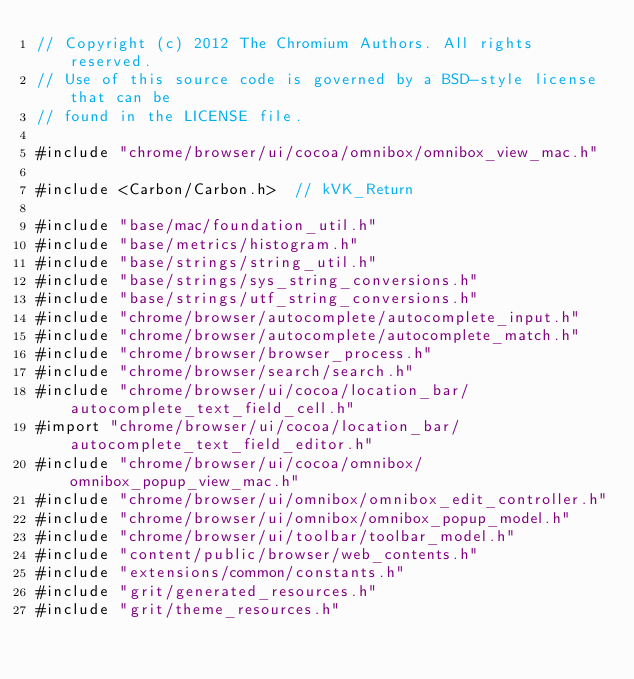<code> <loc_0><loc_0><loc_500><loc_500><_ObjectiveC_>// Copyright (c) 2012 The Chromium Authors. All rights reserved.
// Use of this source code is governed by a BSD-style license that can be
// found in the LICENSE file.

#include "chrome/browser/ui/cocoa/omnibox/omnibox_view_mac.h"

#include <Carbon/Carbon.h>  // kVK_Return

#include "base/mac/foundation_util.h"
#include "base/metrics/histogram.h"
#include "base/strings/string_util.h"
#include "base/strings/sys_string_conversions.h"
#include "base/strings/utf_string_conversions.h"
#include "chrome/browser/autocomplete/autocomplete_input.h"
#include "chrome/browser/autocomplete/autocomplete_match.h"
#include "chrome/browser/browser_process.h"
#include "chrome/browser/search/search.h"
#include "chrome/browser/ui/cocoa/location_bar/autocomplete_text_field_cell.h"
#import "chrome/browser/ui/cocoa/location_bar/autocomplete_text_field_editor.h"
#include "chrome/browser/ui/cocoa/omnibox/omnibox_popup_view_mac.h"
#include "chrome/browser/ui/omnibox/omnibox_edit_controller.h"
#include "chrome/browser/ui/omnibox/omnibox_popup_model.h"
#include "chrome/browser/ui/toolbar/toolbar_model.h"
#include "content/public/browser/web_contents.h"
#include "extensions/common/constants.h"
#include "grit/generated_resources.h"
#include "grit/theme_resources.h"</code> 